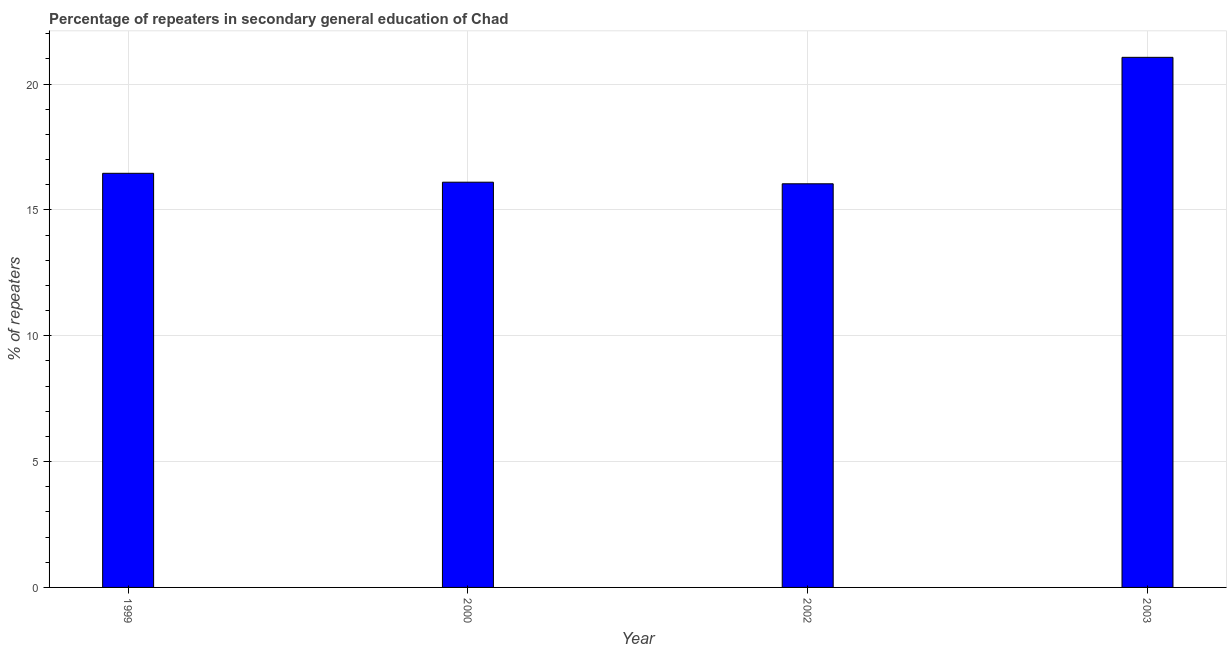Does the graph contain any zero values?
Ensure brevity in your answer.  No. Does the graph contain grids?
Your response must be concise. Yes. What is the title of the graph?
Your answer should be very brief. Percentage of repeaters in secondary general education of Chad. What is the label or title of the X-axis?
Your answer should be compact. Year. What is the label or title of the Y-axis?
Offer a very short reply. % of repeaters. What is the percentage of repeaters in 2000?
Keep it short and to the point. 16.1. Across all years, what is the maximum percentage of repeaters?
Provide a succinct answer. 21.07. Across all years, what is the minimum percentage of repeaters?
Your answer should be compact. 16.04. In which year was the percentage of repeaters minimum?
Provide a short and direct response. 2002. What is the sum of the percentage of repeaters?
Your response must be concise. 69.67. What is the difference between the percentage of repeaters in 1999 and 2000?
Provide a succinct answer. 0.35. What is the average percentage of repeaters per year?
Provide a short and direct response. 17.42. What is the median percentage of repeaters?
Your answer should be compact. 16.28. In how many years, is the percentage of repeaters greater than 18 %?
Make the answer very short. 1. What is the ratio of the percentage of repeaters in 2000 to that in 2003?
Keep it short and to the point. 0.76. Is the difference between the percentage of repeaters in 2002 and 2003 greater than the difference between any two years?
Offer a terse response. Yes. What is the difference between the highest and the second highest percentage of repeaters?
Offer a terse response. 4.61. What is the difference between the highest and the lowest percentage of repeaters?
Your answer should be very brief. 5.03. In how many years, is the percentage of repeaters greater than the average percentage of repeaters taken over all years?
Your answer should be very brief. 1. How many bars are there?
Your answer should be compact. 4. Are all the bars in the graph horizontal?
Keep it short and to the point. No. How many years are there in the graph?
Offer a terse response. 4. What is the % of repeaters of 1999?
Make the answer very short. 16.46. What is the % of repeaters of 2000?
Your response must be concise. 16.1. What is the % of repeaters of 2002?
Provide a short and direct response. 16.04. What is the % of repeaters in 2003?
Ensure brevity in your answer.  21.07. What is the difference between the % of repeaters in 1999 and 2000?
Give a very brief answer. 0.35. What is the difference between the % of repeaters in 1999 and 2002?
Make the answer very short. 0.42. What is the difference between the % of repeaters in 1999 and 2003?
Offer a terse response. -4.61. What is the difference between the % of repeaters in 2000 and 2002?
Provide a short and direct response. 0.06. What is the difference between the % of repeaters in 2000 and 2003?
Your answer should be very brief. -4.96. What is the difference between the % of repeaters in 2002 and 2003?
Give a very brief answer. -5.03. What is the ratio of the % of repeaters in 1999 to that in 2003?
Provide a succinct answer. 0.78. What is the ratio of the % of repeaters in 2000 to that in 2003?
Offer a terse response. 0.76. What is the ratio of the % of repeaters in 2002 to that in 2003?
Ensure brevity in your answer.  0.76. 